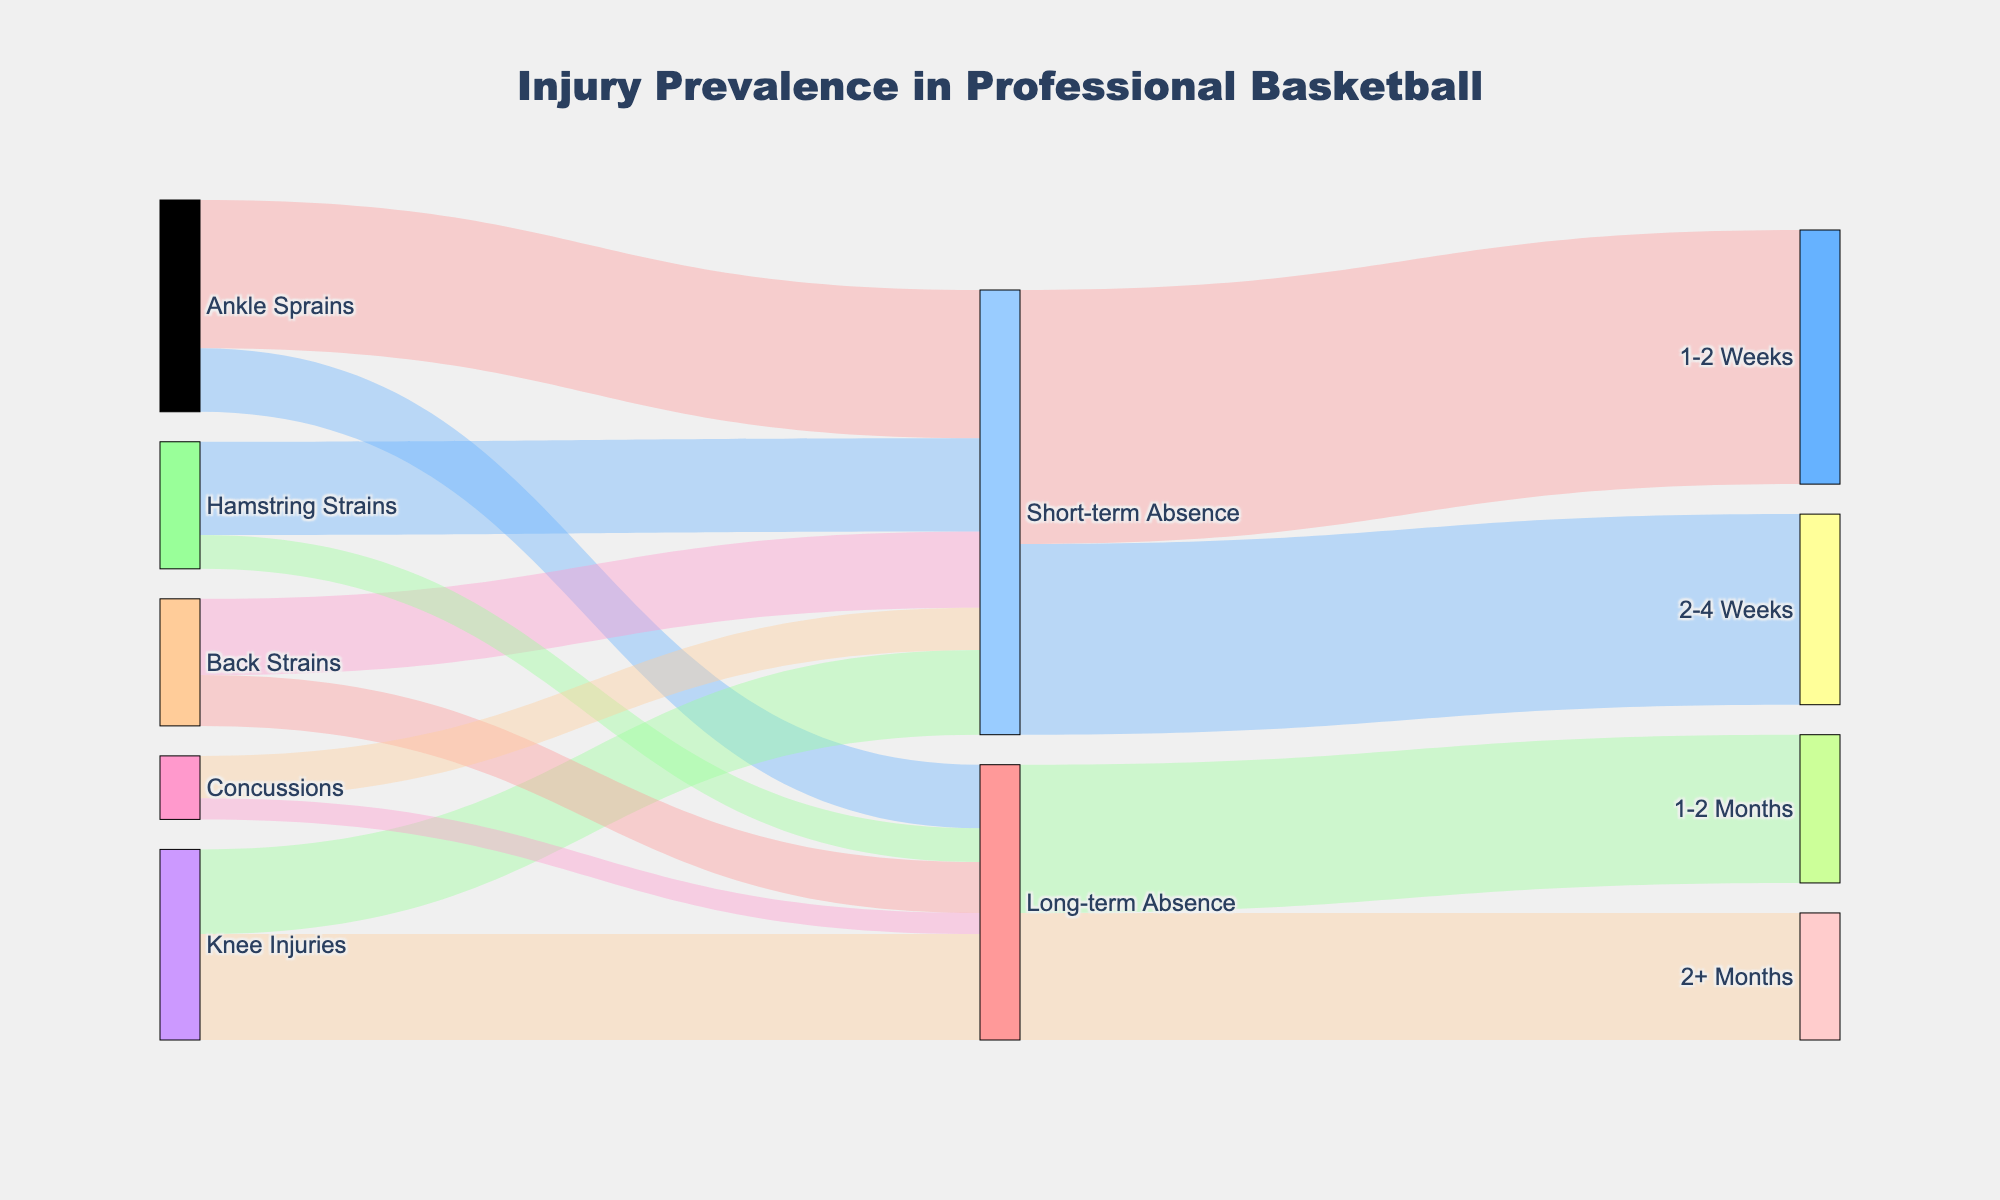What is the title of the figure? The title is the main heading often displayed prominently at the top of the figure. It tells us the overall subject or focus of the diagram.
Answer: Injury Prevalence in Professional Basketball Which type of injury has the highest short-term absence? Look at the connections between 'Ankle Sprains,' 'Knee Injuries,' 'Back Strains,' 'Hamstring Strains,' and 'Concussions' to 'Short-term Absence,' then identify the largest value.
Answer: Ankle Sprains How many injuries lead to long-term absences? Add up the values connecting each injury type to 'Long-term Absence'. This requires summing 15 (Ankle Sprains), 25 (Knee Injuries), 12 (Back Strains), 8 (Hamstring Strains), and 5 (Concussions).
Answer: 65 Which injury type results in the smallest number of long-term absences? Compare the values connecting all injury types to 'Long-term Absence'. Identify the injury type with the smallest value.
Answer: Concussions How many short-term absences last between 1-2 weeks? Look at the value connecting 'Short-term Absence' to '1-2 Weeks'.
Answer: 60 What is the total number of absences (short-term + long-term)? Sum the values connecting to either 'Short-term Absence' or 'Long-term Absence'; 60 (1-2 Weeks) + 45 (2-4 Weeks) + 35 (1-2 Months) + 30 (2+ Months).
Answer: 170 What percentage of knee injuries result in long-term absences? Divide the long-term absence value for 'Knee Injuries' by the sum of all 'Knee Injuries' values, then multiply by 100. (25 from long-term over 45 total).
Answer: 55.56% Which type of absence (short-term or long-term) is more common? Compare the total values associated with 'Short-term Absence' and 'Long-term Absence'. Sum each set of values and compare.
Answer: Short-term Absence How many injuries lead to absences lasting more than 1 month? Sum the values for absences '1-2 Months' and '2+ Months' under 'Long-term Absence'.
Answer: 65 What percentage of total 'Short-term Absence' results in 2-4 weeks absences? Divide the value for '2-4 Weeks' by the total 'Short-term Absence' value (45/105), then multiply by 100.
Answer: 42.86% 